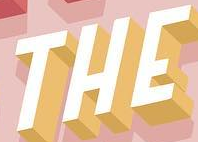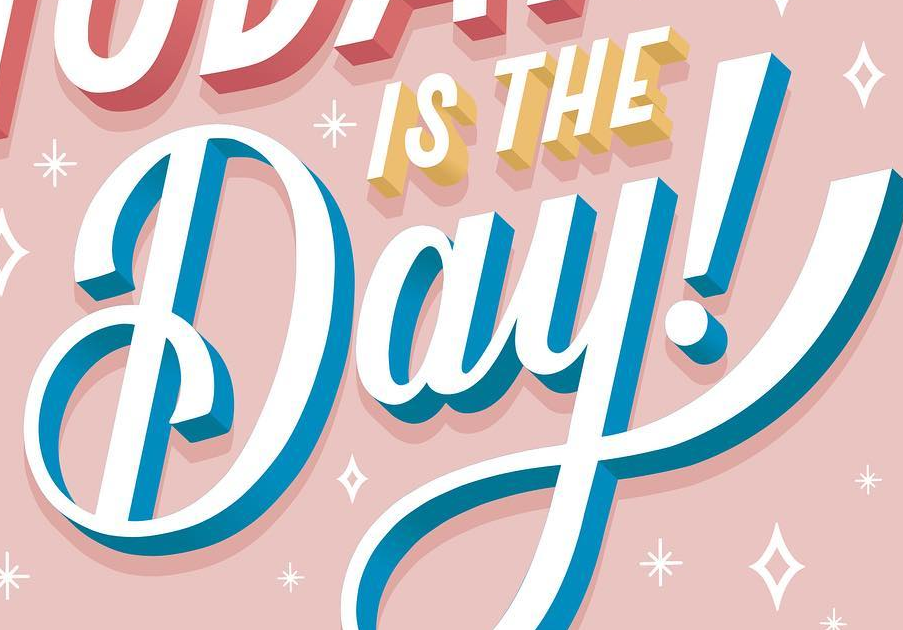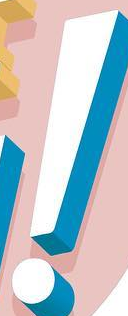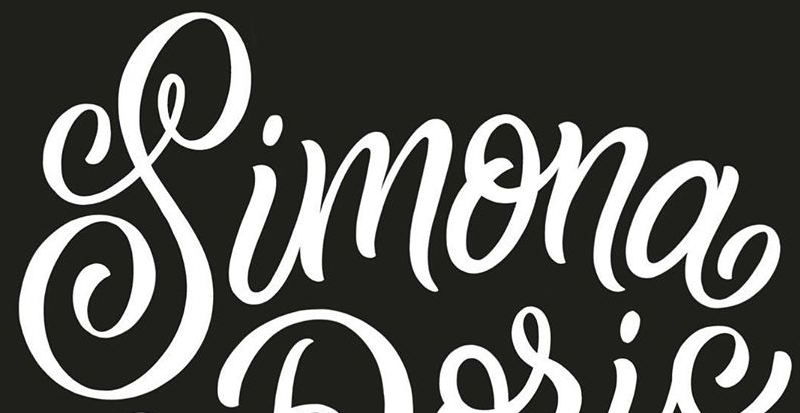Identify the words shown in these images in order, separated by a semicolon. THE; Day; !; Simona 